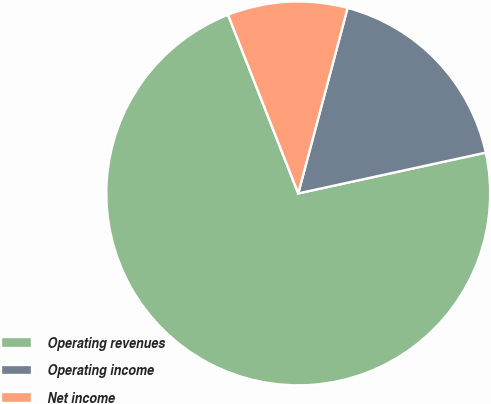Convert chart to OTSL. <chart><loc_0><loc_0><loc_500><loc_500><pie_chart><fcel>Operating revenues<fcel>Operating income<fcel>Net income<nl><fcel>72.45%<fcel>17.45%<fcel>10.1%<nl></chart> 